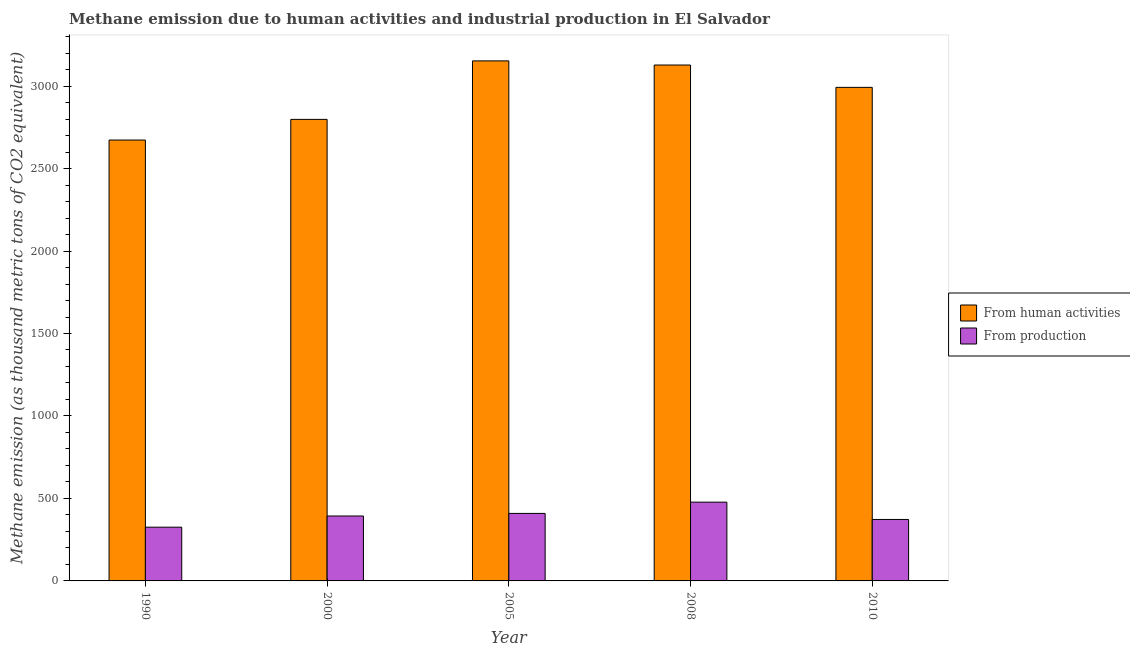How many different coloured bars are there?
Your response must be concise. 2. How many groups of bars are there?
Ensure brevity in your answer.  5. How many bars are there on the 5th tick from the right?
Provide a short and direct response. 2. What is the amount of emissions from human activities in 2005?
Keep it short and to the point. 3152.8. Across all years, what is the maximum amount of emissions generated from industries?
Provide a succinct answer. 477.6. Across all years, what is the minimum amount of emissions from human activities?
Keep it short and to the point. 2672.9. In which year was the amount of emissions generated from industries maximum?
Offer a very short reply. 2008. What is the total amount of emissions from human activities in the graph?
Keep it short and to the point. 1.47e+04. What is the difference between the amount of emissions from human activities in 2008 and that in 2010?
Your answer should be very brief. 135.5. What is the difference between the amount of emissions generated from industries in 2000 and the amount of emissions from human activities in 2005?
Offer a terse response. -15.7. What is the average amount of emissions from human activities per year?
Ensure brevity in your answer.  2948.74. In the year 2010, what is the difference between the amount of emissions from human activities and amount of emissions generated from industries?
Give a very brief answer. 0. In how many years, is the amount of emissions from human activities greater than 1300 thousand metric tons?
Provide a succinct answer. 5. What is the ratio of the amount of emissions from human activities in 1990 to that in 2000?
Provide a succinct answer. 0.96. Is the amount of emissions generated from industries in 2000 less than that in 2008?
Offer a terse response. Yes. What is the difference between the highest and the second highest amount of emissions generated from industries?
Provide a succinct answer. 68.3. What is the difference between the highest and the lowest amount of emissions from human activities?
Keep it short and to the point. 479.9. In how many years, is the amount of emissions from human activities greater than the average amount of emissions from human activities taken over all years?
Ensure brevity in your answer.  3. Is the sum of the amount of emissions generated from industries in 2000 and 2005 greater than the maximum amount of emissions from human activities across all years?
Offer a very short reply. Yes. What does the 2nd bar from the left in 2000 represents?
Provide a short and direct response. From production. What does the 2nd bar from the right in 1990 represents?
Ensure brevity in your answer.  From human activities. How many years are there in the graph?
Your answer should be very brief. 5. Are the values on the major ticks of Y-axis written in scientific E-notation?
Offer a very short reply. No. Does the graph contain any zero values?
Give a very brief answer. No. Does the graph contain grids?
Your answer should be very brief. No. How many legend labels are there?
Make the answer very short. 2. How are the legend labels stacked?
Your answer should be compact. Vertical. What is the title of the graph?
Keep it short and to the point. Methane emission due to human activities and industrial production in El Salvador. Does "Start a business" appear as one of the legend labels in the graph?
Offer a very short reply. No. What is the label or title of the X-axis?
Your answer should be very brief. Year. What is the label or title of the Y-axis?
Ensure brevity in your answer.  Methane emission (as thousand metric tons of CO2 equivalent). What is the Methane emission (as thousand metric tons of CO2 equivalent) of From human activities in 1990?
Your answer should be compact. 2672.9. What is the Methane emission (as thousand metric tons of CO2 equivalent) of From production in 1990?
Your answer should be compact. 325.8. What is the Methane emission (as thousand metric tons of CO2 equivalent) of From human activities in 2000?
Give a very brief answer. 2798.1. What is the Methane emission (as thousand metric tons of CO2 equivalent) of From production in 2000?
Give a very brief answer. 393.6. What is the Methane emission (as thousand metric tons of CO2 equivalent) of From human activities in 2005?
Offer a terse response. 3152.8. What is the Methane emission (as thousand metric tons of CO2 equivalent) of From production in 2005?
Make the answer very short. 409.3. What is the Methane emission (as thousand metric tons of CO2 equivalent) in From human activities in 2008?
Provide a succinct answer. 3127.7. What is the Methane emission (as thousand metric tons of CO2 equivalent) of From production in 2008?
Your answer should be compact. 477.6. What is the Methane emission (as thousand metric tons of CO2 equivalent) of From human activities in 2010?
Provide a succinct answer. 2992.2. What is the Methane emission (as thousand metric tons of CO2 equivalent) in From production in 2010?
Your response must be concise. 372.6. Across all years, what is the maximum Methane emission (as thousand metric tons of CO2 equivalent) of From human activities?
Keep it short and to the point. 3152.8. Across all years, what is the maximum Methane emission (as thousand metric tons of CO2 equivalent) in From production?
Your response must be concise. 477.6. Across all years, what is the minimum Methane emission (as thousand metric tons of CO2 equivalent) in From human activities?
Your response must be concise. 2672.9. Across all years, what is the minimum Methane emission (as thousand metric tons of CO2 equivalent) of From production?
Your answer should be very brief. 325.8. What is the total Methane emission (as thousand metric tons of CO2 equivalent) of From human activities in the graph?
Make the answer very short. 1.47e+04. What is the total Methane emission (as thousand metric tons of CO2 equivalent) in From production in the graph?
Your answer should be compact. 1978.9. What is the difference between the Methane emission (as thousand metric tons of CO2 equivalent) of From human activities in 1990 and that in 2000?
Your response must be concise. -125.2. What is the difference between the Methane emission (as thousand metric tons of CO2 equivalent) of From production in 1990 and that in 2000?
Your answer should be very brief. -67.8. What is the difference between the Methane emission (as thousand metric tons of CO2 equivalent) of From human activities in 1990 and that in 2005?
Offer a terse response. -479.9. What is the difference between the Methane emission (as thousand metric tons of CO2 equivalent) of From production in 1990 and that in 2005?
Give a very brief answer. -83.5. What is the difference between the Methane emission (as thousand metric tons of CO2 equivalent) of From human activities in 1990 and that in 2008?
Ensure brevity in your answer.  -454.8. What is the difference between the Methane emission (as thousand metric tons of CO2 equivalent) in From production in 1990 and that in 2008?
Give a very brief answer. -151.8. What is the difference between the Methane emission (as thousand metric tons of CO2 equivalent) in From human activities in 1990 and that in 2010?
Your answer should be compact. -319.3. What is the difference between the Methane emission (as thousand metric tons of CO2 equivalent) in From production in 1990 and that in 2010?
Offer a terse response. -46.8. What is the difference between the Methane emission (as thousand metric tons of CO2 equivalent) of From human activities in 2000 and that in 2005?
Your response must be concise. -354.7. What is the difference between the Methane emission (as thousand metric tons of CO2 equivalent) of From production in 2000 and that in 2005?
Provide a short and direct response. -15.7. What is the difference between the Methane emission (as thousand metric tons of CO2 equivalent) of From human activities in 2000 and that in 2008?
Provide a short and direct response. -329.6. What is the difference between the Methane emission (as thousand metric tons of CO2 equivalent) in From production in 2000 and that in 2008?
Keep it short and to the point. -84. What is the difference between the Methane emission (as thousand metric tons of CO2 equivalent) of From human activities in 2000 and that in 2010?
Your answer should be very brief. -194.1. What is the difference between the Methane emission (as thousand metric tons of CO2 equivalent) in From human activities in 2005 and that in 2008?
Offer a terse response. 25.1. What is the difference between the Methane emission (as thousand metric tons of CO2 equivalent) in From production in 2005 and that in 2008?
Offer a terse response. -68.3. What is the difference between the Methane emission (as thousand metric tons of CO2 equivalent) in From human activities in 2005 and that in 2010?
Provide a short and direct response. 160.6. What is the difference between the Methane emission (as thousand metric tons of CO2 equivalent) in From production in 2005 and that in 2010?
Your answer should be very brief. 36.7. What is the difference between the Methane emission (as thousand metric tons of CO2 equivalent) in From human activities in 2008 and that in 2010?
Your response must be concise. 135.5. What is the difference between the Methane emission (as thousand metric tons of CO2 equivalent) in From production in 2008 and that in 2010?
Provide a short and direct response. 105. What is the difference between the Methane emission (as thousand metric tons of CO2 equivalent) of From human activities in 1990 and the Methane emission (as thousand metric tons of CO2 equivalent) of From production in 2000?
Provide a succinct answer. 2279.3. What is the difference between the Methane emission (as thousand metric tons of CO2 equivalent) in From human activities in 1990 and the Methane emission (as thousand metric tons of CO2 equivalent) in From production in 2005?
Your answer should be compact. 2263.6. What is the difference between the Methane emission (as thousand metric tons of CO2 equivalent) of From human activities in 1990 and the Methane emission (as thousand metric tons of CO2 equivalent) of From production in 2008?
Offer a terse response. 2195.3. What is the difference between the Methane emission (as thousand metric tons of CO2 equivalent) of From human activities in 1990 and the Methane emission (as thousand metric tons of CO2 equivalent) of From production in 2010?
Offer a very short reply. 2300.3. What is the difference between the Methane emission (as thousand metric tons of CO2 equivalent) in From human activities in 2000 and the Methane emission (as thousand metric tons of CO2 equivalent) in From production in 2005?
Offer a terse response. 2388.8. What is the difference between the Methane emission (as thousand metric tons of CO2 equivalent) in From human activities in 2000 and the Methane emission (as thousand metric tons of CO2 equivalent) in From production in 2008?
Your answer should be very brief. 2320.5. What is the difference between the Methane emission (as thousand metric tons of CO2 equivalent) of From human activities in 2000 and the Methane emission (as thousand metric tons of CO2 equivalent) of From production in 2010?
Ensure brevity in your answer.  2425.5. What is the difference between the Methane emission (as thousand metric tons of CO2 equivalent) of From human activities in 2005 and the Methane emission (as thousand metric tons of CO2 equivalent) of From production in 2008?
Your response must be concise. 2675.2. What is the difference between the Methane emission (as thousand metric tons of CO2 equivalent) of From human activities in 2005 and the Methane emission (as thousand metric tons of CO2 equivalent) of From production in 2010?
Offer a very short reply. 2780.2. What is the difference between the Methane emission (as thousand metric tons of CO2 equivalent) of From human activities in 2008 and the Methane emission (as thousand metric tons of CO2 equivalent) of From production in 2010?
Your response must be concise. 2755.1. What is the average Methane emission (as thousand metric tons of CO2 equivalent) in From human activities per year?
Your answer should be very brief. 2948.74. What is the average Methane emission (as thousand metric tons of CO2 equivalent) of From production per year?
Your answer should be compact. 395.78. In the year 1990, what is the difference between the Methane emission (as thousand metric tons of CO2 equivalent) in From human activities and Methane emission (as thousand metric tons of CO2 equivalent) in From production?
Your response must be concise. 2347.1. In the year 2000, what is the difference between the Methane emission (as thousand metric tons of CO2 equivalent) in From human activities and Methane emission (as thousand metric tons of CO2 equivalent) in From production?
Offer a terse response. 2404.5. In the year 2005, what is the difference between the Methane emission (as thousand metric tons of CO2 equivalent) of From human activities and Methane emission (as thousand metric tons of CO2 equivalent) of From production?
Give a very brief answer. 2743.5. In the year 2008, what is the difference between the Methane emission (as thousand metric tons of CO2 equivalent) in From human activities and Methane emission (as thousand metric tons of CO2 equivalent) in From production?
Your response must be concise. 2650.1. In the year 2010, what is the difference between the Methane emission (as thousand metric tons of CO2 equivalent) in From human activities and Methane emission (as thousand metric tons of CO2 equivalent) in From production?
Keep it short and to the point. 2619.6. What is the ratio of the Methane emission (as thousand metric tons of CO2 equivalent) in From human activities in 1990 to that in 2000?
Give a very brief answer. 0.96. What is the ratio of the Methane emission (as thousand metric tons of CO2 equivalent) in From production in 1990 to that in 2000?
Keep it short and to the point. 0.83. What is the ratio of the Methane emission (as thousand metric tons of CO2 equivalent) of From human activities in 1990 to that in 2005?
Provide a short and direct response. 0.85. What is the ratio of the Methane emission (as thousand metric tons of CO2 equivalent) in From production in 1990 to that in 2005?
Provide a short and direct response. 0.8. What is the ratio of the Methane emission (as thousand metric tons of CO2 equivalent) of From human activities in 1990 to that in 2008?
Provide a short and direct response. 0.85. What is the ratio of the Methane emission (as thousand metric tons of CO2 equivalent) in From production in 1990 to that in 2008?
Provide a short and direct response. 0.68. What is the ratio of the Methane emission (as thousand metric tons of CO2 equivalent) of From human activities in 1990 to that in 2010?
Offer a terse response. 0.89. What is the ratio of the Methane emission (as thousand metric tons of CO2 equivalent) in From production in 1990 to that in 2010?
Give a very brief answer. 0.87. What is the ratio of the Methane emission (as thousand metric tons of CO2 equivalent) of From human activities in 2000 to that in 2005?
Your answer should be compact. 0.89. What is the ratio of the Methane emission (as thousand metric tons of CO2 equivalent) of From production in 2000 to that in 2005?
Your response must be concise. 0.96. What is the ratio of the Methane emission (as thousand metric tons of CO2 equivalent) of From human activities in 2000 to that in 2008?
Offer a very short reply. 0.89. What is the ratio of the Methane emission (as thousand metric tons of CO2 equivalent) in From production in 2000 to that in 2008?
Give a very brief answer. 0.82. What is the ratio of the Methane emission (as thousand metric tons of CO2 equivalent) in From human activities in 2000 to that in 2010?
Ensure brevity in your answer.  0.94. What is the ratio of the Methane emission (as thousand metric tons of CO2 equivalent) in From production in 2000 to that in 2010?
Offer a terse response. 1.06. What is the ratio of the Methane emission (as thousand metric tons of CO2 equivalent) in From production in 2005 to that in 2008?
Provide a succinct answer. 0.86. What is the ratio of the Methane emission (as thousand metric tons of CO2 equivalent) of From human activities in 2005 to that in 2010?
Offer a terse response. 1.05. What is the ratio of the Methane emission (as thousand metric tons of CO2 equivalent) in From production in 2005 to that in 2010?
Provide a short and direct response. 1.1. What is the ratio of the Methane emission (as thousand metric tons of CO2 equivalent) of From human activities in 2008 to that in 2010?
Your response must be concise. 1.05. What is the ratio of the Methane emission (as thousand metric tons of CO2 equivalent) in From production in 2008 to that in 2010?
Your answer should be compact. 1.28. What is the difference between the highest and the second highest Methane emission (as thousand metric tons of CO2 equivalent) of From human activities?
Provide a short and direct response. 25.1. What is the difference between the highest and the second highest Methane emission (as thousand metric tons of CO2 equivalent) of From production?
Give a very brief answer. 68.3. What is the difference between the highest and the lowest Methane emission (as thousand metric tons of CO2 equivalent) of From human activities?
Make the answer very short. 479.9. What is the difference between the highest and the lowest Methane emission (as thousand metric tons of CO2 equivalent) in From production?
Offer a terse response. 151.8. 